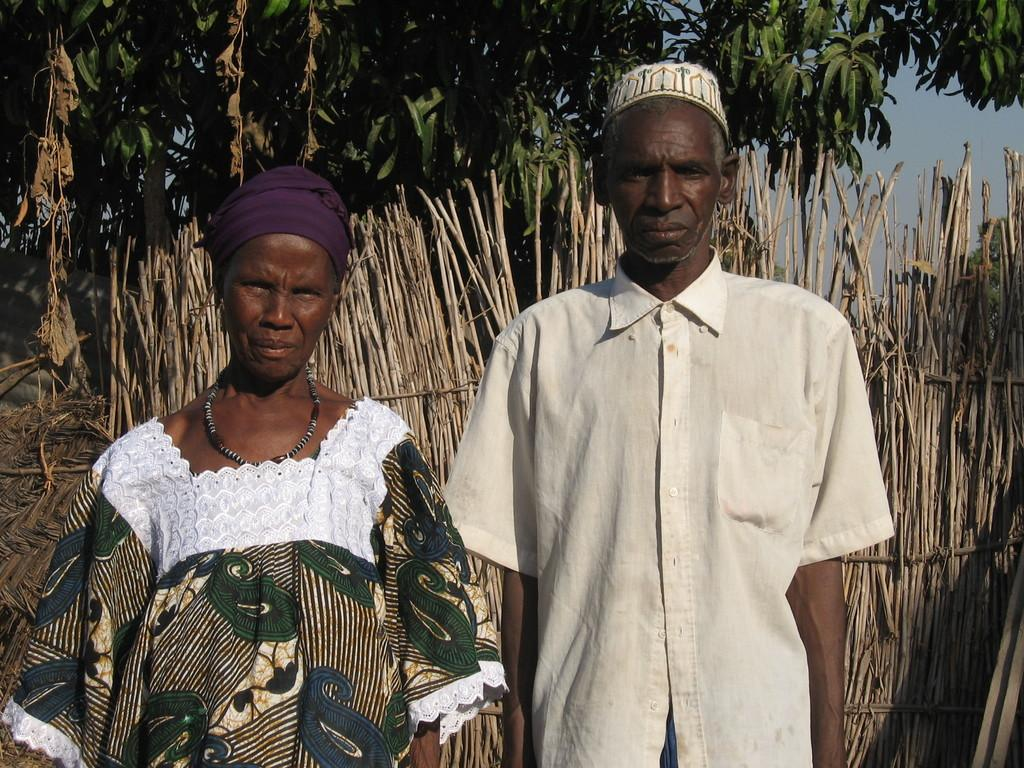How many people are in the image? There are two people in the image. What are the people wearing on their heads? The people are wearing caps. What colors are the dresses of the two people? The people are wearing different color dresses. What can be seen in the background of the image? There are wooden sticks, many trees, and the sky visible in the background. Can you see a sail in the image? There is no sail present in the image. What type of bit is being used by the people in the image? There are no bits visible in the image, as it features people wearing caps and dresses, with no indication of any bit-related activity. 